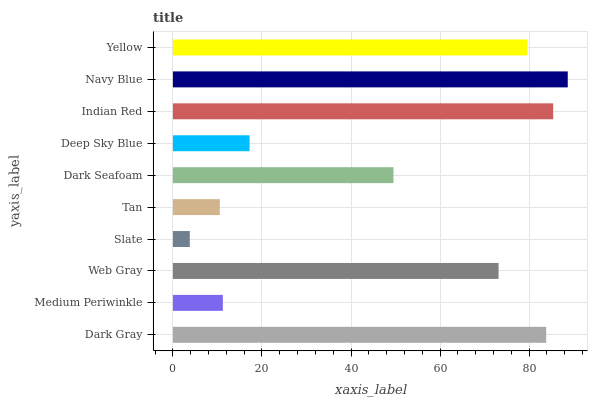Is Slate the minimum?
Answer yes or no. Yes. Is Navy Blue the maximum?
Answer yes or no. Yes. Is Medium Periwinkle the minimum?
Answer yes or no. No. Is Medium Periwinkle the maximum?
Answer yes or no. No. Is Dark Gray greater than Medium Periwinkle?
Answer yes or no. Yes. Is Medium Periwinkle less than Dark Gray?
Answer yes or no. Yes. Is Medium Periwinkle greater than Dark Gray?
Answer yes or no. No. Is Dark Gray less than Medium Periwinkle?
Answer yes or no. No. Is Web Gray the high median?
Answer yes or no. Yes. Is Dark Seafoam the low median?
Answer yes or no. Yes. Is Slate the high median?
Answer yes or no. No. Is Indian Red the low median?
Answer yes or no. No. 